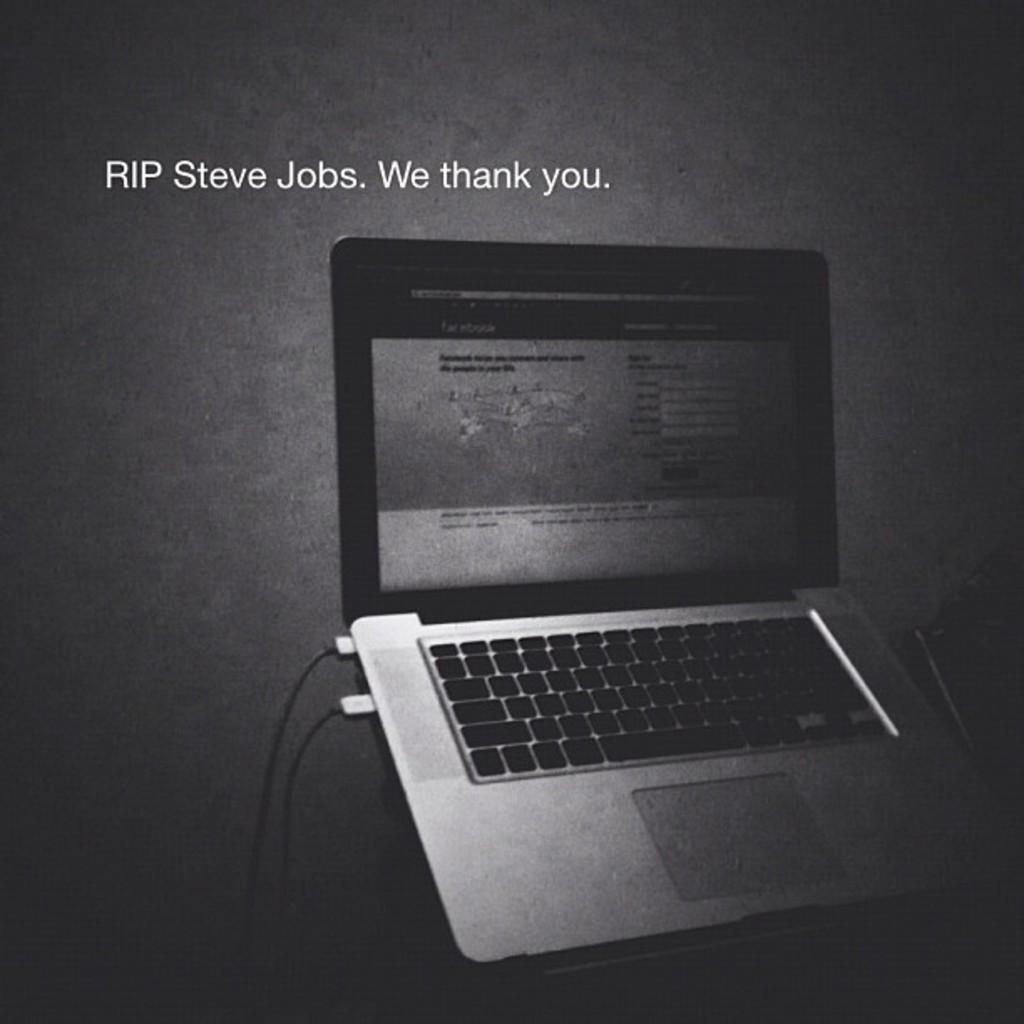<image>
Write a terse but informative summary of the picture. An open laptop sits below copy referencing Steve Job's death. 